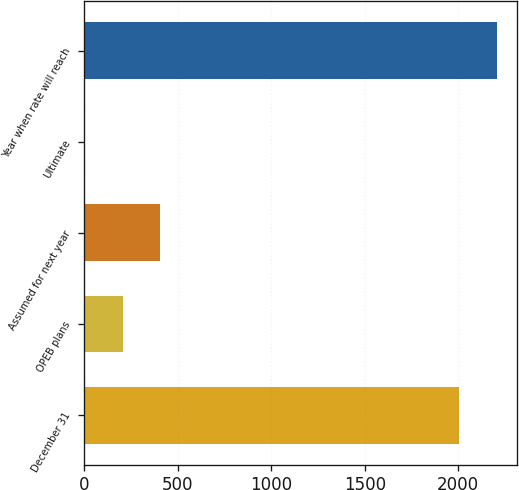Convert chart to OTSL. <chart><loc_0><loc_0><loc_500><loc_500><bar_chart><fcel>December 31<fcel>OPEB plans<fcel>Assumed for next year<fcel>Ultimate<fcel>Year when rate will reach<nl><fcel>2006<fcel>205.9<fcel>406.8<fcel>5<fcel>2206.9<nl></chart> 